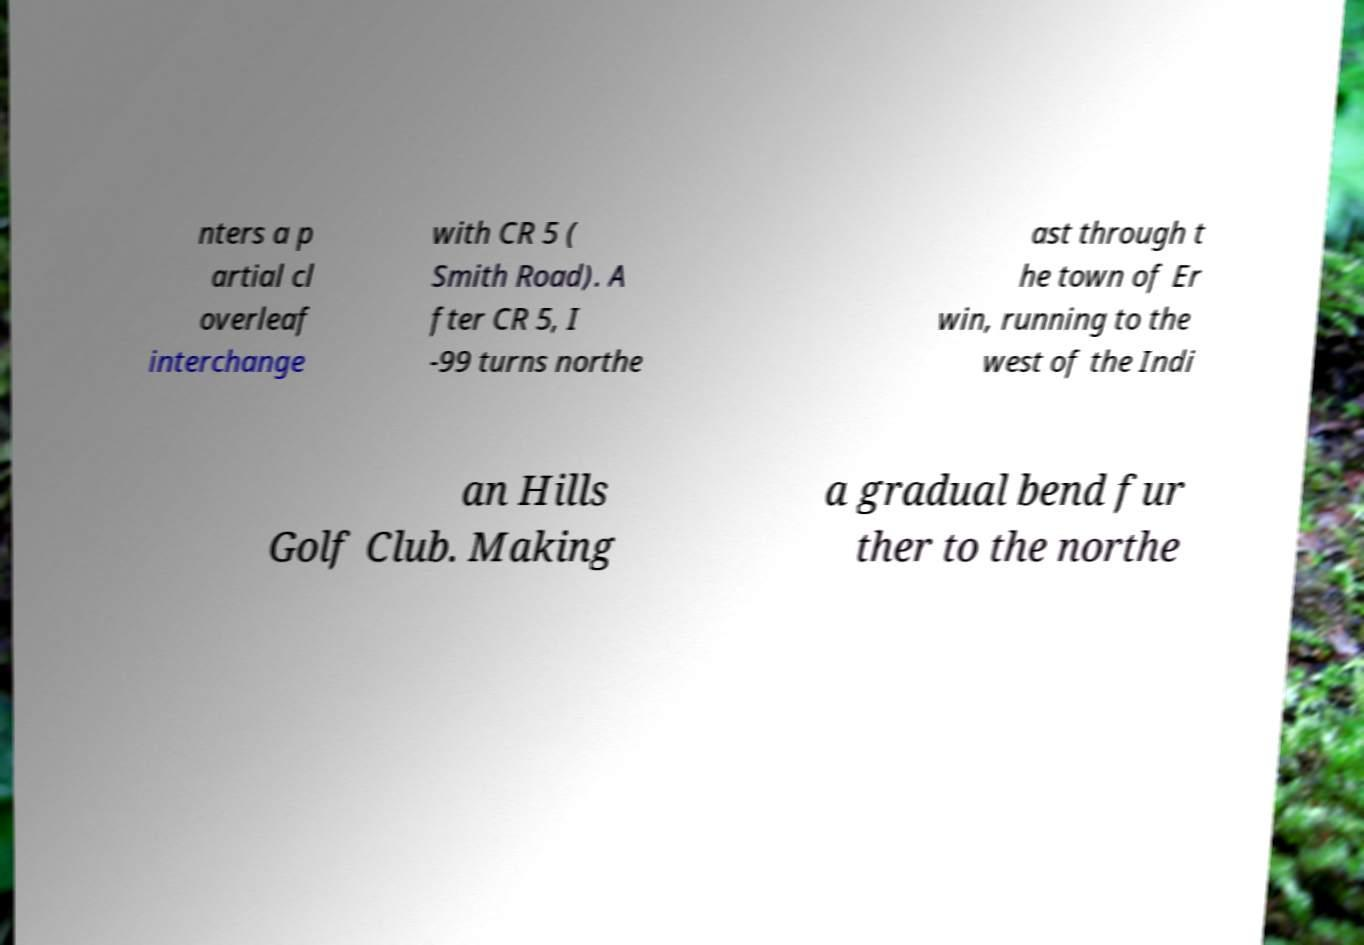There's text embedded in this image that I need extracted. Can you transcribe it verbatim? nters a p artial cl overleaf interchange with CR 5 ( Smith Road). A fter CR 5, I -99 turns northe ast through t he town of Er win, running to the west of the Indi an Hills Golf Club. Making a gradual bend fur ther to the northe 